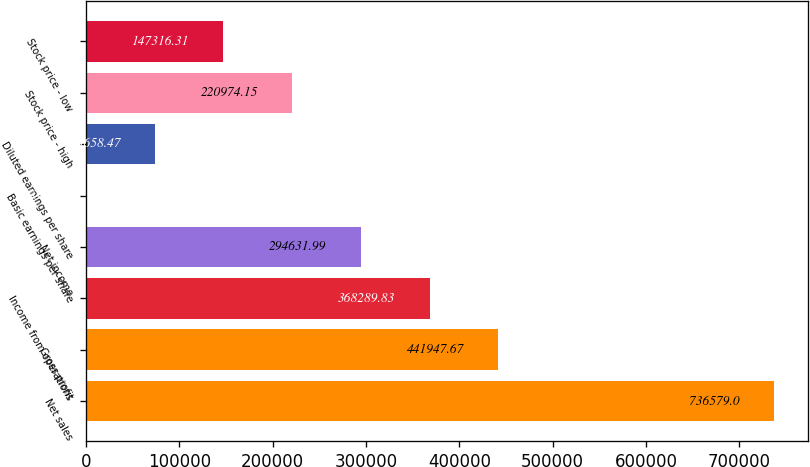<chart> <loc_0><loc_0><loc_500><loc_500><bar_chart><fcel>Net sales<fcel>Gross profit<fcel>Income from operations<fcel>Net income<fcel>Basic earnings per share<fcel>Diluted earnings per share<fcel>Stock price - high<fcel>Stock price - low<nl><fcel>736579<fcel>441948<fcel>368290<fcel>294632<fcel>0.63<fcel>73658.5<fcel>220974<fcel>147316<nl></chart> 